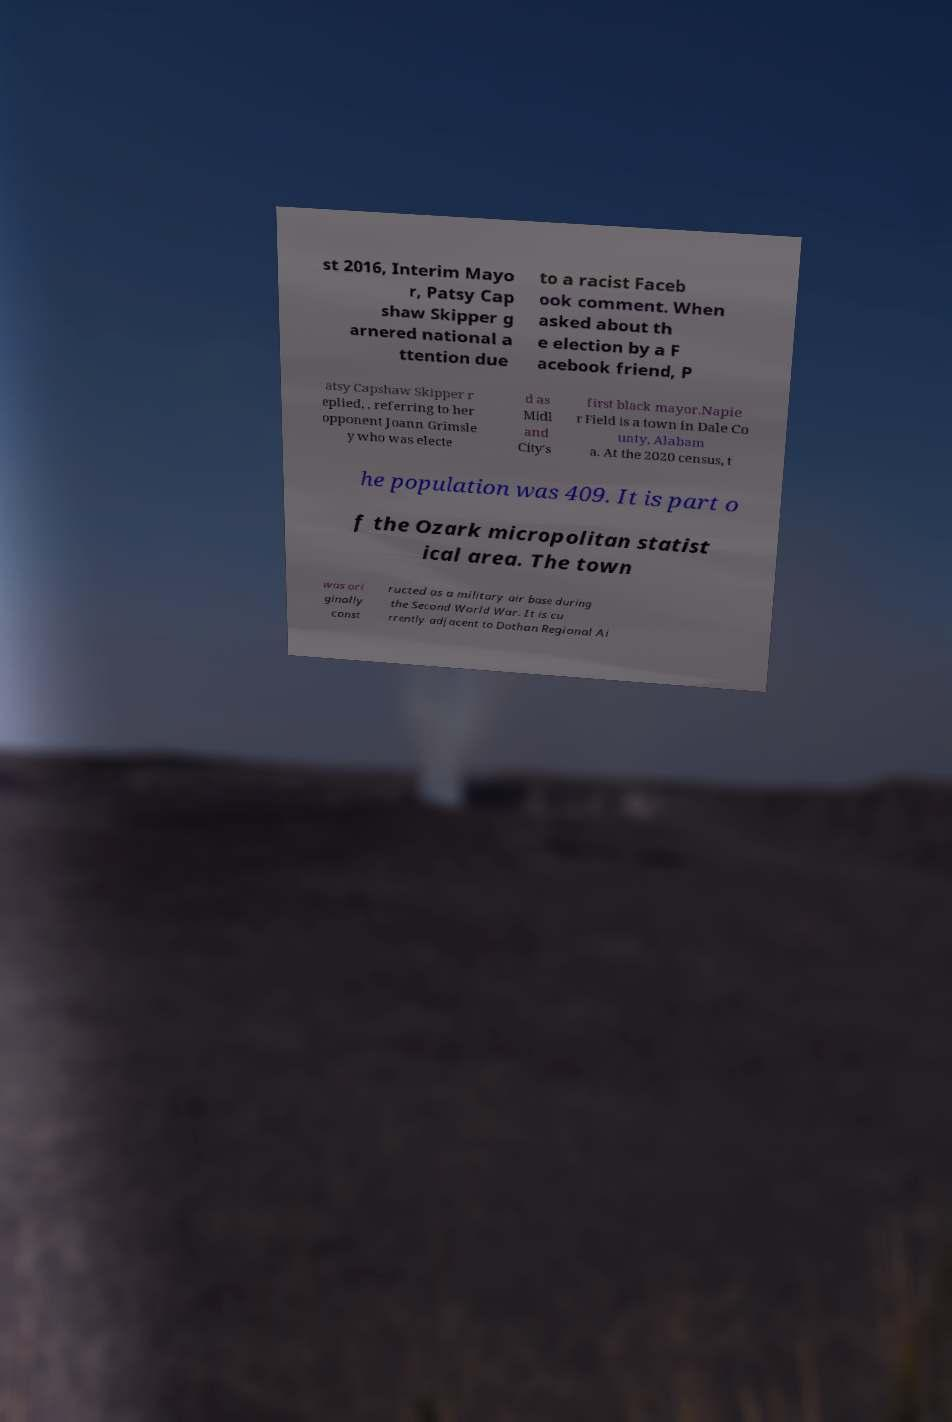For documentation purposes, I need the text within this image transcribed. Could you provide that? st 2016, Interim Mayo r, Patsy Cap shaw Skipper g arnered national a ttention due to a racist Faceb ook comment. When asked about th e election by a F acebook friend, P atsy Capshaw Skipper r eplied, , referring to her opponent Joann Grimsle y who was electe d as Midl and City's first black mayor.Napie r Field is a town in Dale Co unty, Alabam a. At the 2020 census, t he population was 409. It is part o f the Ozark micropolitan statist ical area. The town was ori ginally const ructed as a military air base during the Second World War. It is cu rrently adjacent to Dothan Regional Ai 